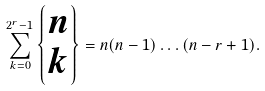Convert formula to latex. <formula><loc_0><loc_0><loc_500><loc_500>\sum ^ { 2 ^ { r } - 1 } _ { k = 0 } \left \{ \begin{matrix} n \\ k \end{matrix} \right \} = n ( n - 1 ) \hdots ( n - r + 1 ) .</formula> 